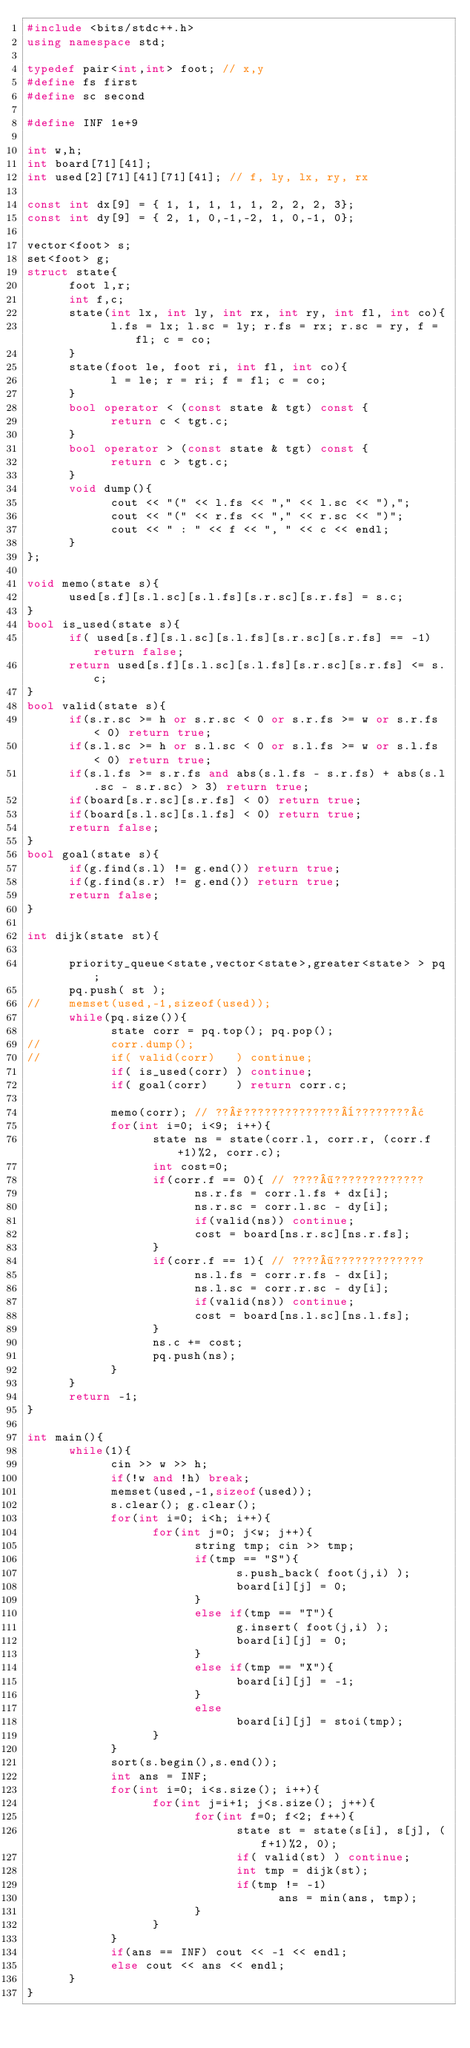<code> <loc_0><loc_0><loc_500><loc_500><_C++_>#include <bits/stdc++.h>
using namespace std;

typedef pair<int,int> foot; // x,y
#define fs first
#define sc second

#define INF 1e+9

int w,h;
int board[71][41];
int used[2][71][41][71][41]; // f, ly, lx, ry, rx

const int dx[9] = { 1, 1, 1, 1, 1, 2, 2, 2, 3};
const int dy[9] = { 2, 1, 0,-1,-2, 1, 0,-1, 0};
	  
vector<foot> s;
set<foot> g;
struct state{
	  foot l,r;
	  int f,c;
	  state(int lx, int ly, int rx, int ry, int fl, int co){
			l.fs = lx; l.sc = ly; r.fs = rx; r.sc = ry, f = fl; c = co;
	  }
	  state(foot le, foot ri, int fl, int co){
			l = le; r = ri; f = fl; c = co;
	  }
	  bool operator < (const state & tgt) const {
			return c < tgt.c;
	  }
	  bool operator > (const state & tgt) const {
			return c > tgt.c;
	  }
	  void dump(){
			cout << "(" << l.fs << "," << l.sc << "),";
			cout << "(" << r.fs << "," << r.sc << ")";
			cout << " : " << f << ", " << c << endl;
	  }
};

void memo(state s){
	  used[s.f][s.l.sc][s.l.fs][s.r.sc][s.r.fs] = s.c;
}
bool is_used(state s){
	  if( used[s.f][s.l.sc][s.l.fs][s.r.sc][s.r.fs] == -1) return false;
	  return used[s.f][s.l.sc][s.l.fs][s.r.sc][s.r.fs] <= s.c;
}
bool valid(state s){
	  if(s.r.sc >= h or s.r.sc < 0 or s.r.fs >= w or s.r.fs < 0) return true;
	  if(s.l.sc >= h or s.l.sc < 0 or s.l.fs >= w or s.l.fs < 0) return true;
	  if(s.l.fs >= s.r.fs and abs(s.l.fs - s.r.fs) + abs(s.l.sc - s.r.sc) > 3) return true; 
	  if(board[s.r.sc][s.r.fs] < 0) return true;
	  if(board[s.l.sc][s.l.fs] < 0) return true;
	  return false;
}
bool goal(state s){
	  if(g.find(s.l) != g.end()) return true;
	  if(g.find(s.r) != g.end()) return true;
	  return false;
}

int dijk(state st){
	  
	  priority_queue<state,vector<state>,greater<state> > pq;
	  pq.push( st );
//	  memset(used,-1,sizeof(used));
	  while(pq.size()){
			state corr = pq.top(); pq.pop();
//			corr.dump();
//			if( valid(corr)   ) continue;
			if( is_used(corr) ) continue;
			if( goal(corr)    ) return corr.c;

			memo(corr); // ??°??????????????¨????????¢
			for(int i=0; i<9; i++){
				  state ns = state(corr.l, corr.r, (corr.f+1)%2, corr.c);
				  int cost=0;
				  if(corr.f == 0){ // ????¶?????????????
						ns.r.fs = corr.l.fs + dx[i];
						ns.r.sc = corr.l.sc - dy[i];
						if(valid(ns)) continue;
						cost = board[ns.r.sc][ns.r.fs];
				  }
				  if(corr.f == 1){ // ????¶?????????????
						ns.l.fs = corr.r.fs - dx[i];
						ns.l.sc = corr.r.sc - dy[i];
						if(valid(ns)) continue;
						cost = board[ns.l.sc][ns.l.fs];
				  }
				  ns.c += cost;
				  pq.push(ns);
			}
	  }
	  return -1;
}

int main(){
	  while(1){
			cin >> w >> h;
			if(!w and !h) break;
			memset(used,-1,sizeof(used));
			s.clear(); g.clear();
			for(int i=0; i<h; i++){
				  for(int j=0; j<w; j++){
						string tmp; cin >> tmp;
						if(tmp == "S"){
							  s.push_back( foot(j,i) );
							  board[i][j] = 0;
						}
						else if(tmp == "T"){
							  g.insert( foot(j,i) );
							  board[i][j] = 0;
						}
						else if(tmp == "X"){
							  board[i][j] = -1;
						}
						else
							  board[i][j] = stoi(tmp);
				  }
			}
			sort(s.begin(),s.end());
			int ans = INF;
			for(int i=0; i<s.size(); i++){
				  for(int j=i+1; j<s.size(); j++){
						for(int f=0; f<2; f++){
							  state st = state(s[i], s[j], (f+1)%2, 0);
							  if( valid(st) ) continue;
							  int tmp = dijk(st);
							  if(tmp != -1)
									ans = min(ans, tmp);
						}
				  }
			}
			if(ans == INF) cout << -1 << endl;
			else cout << ans << endl;
	  }
}</code> 